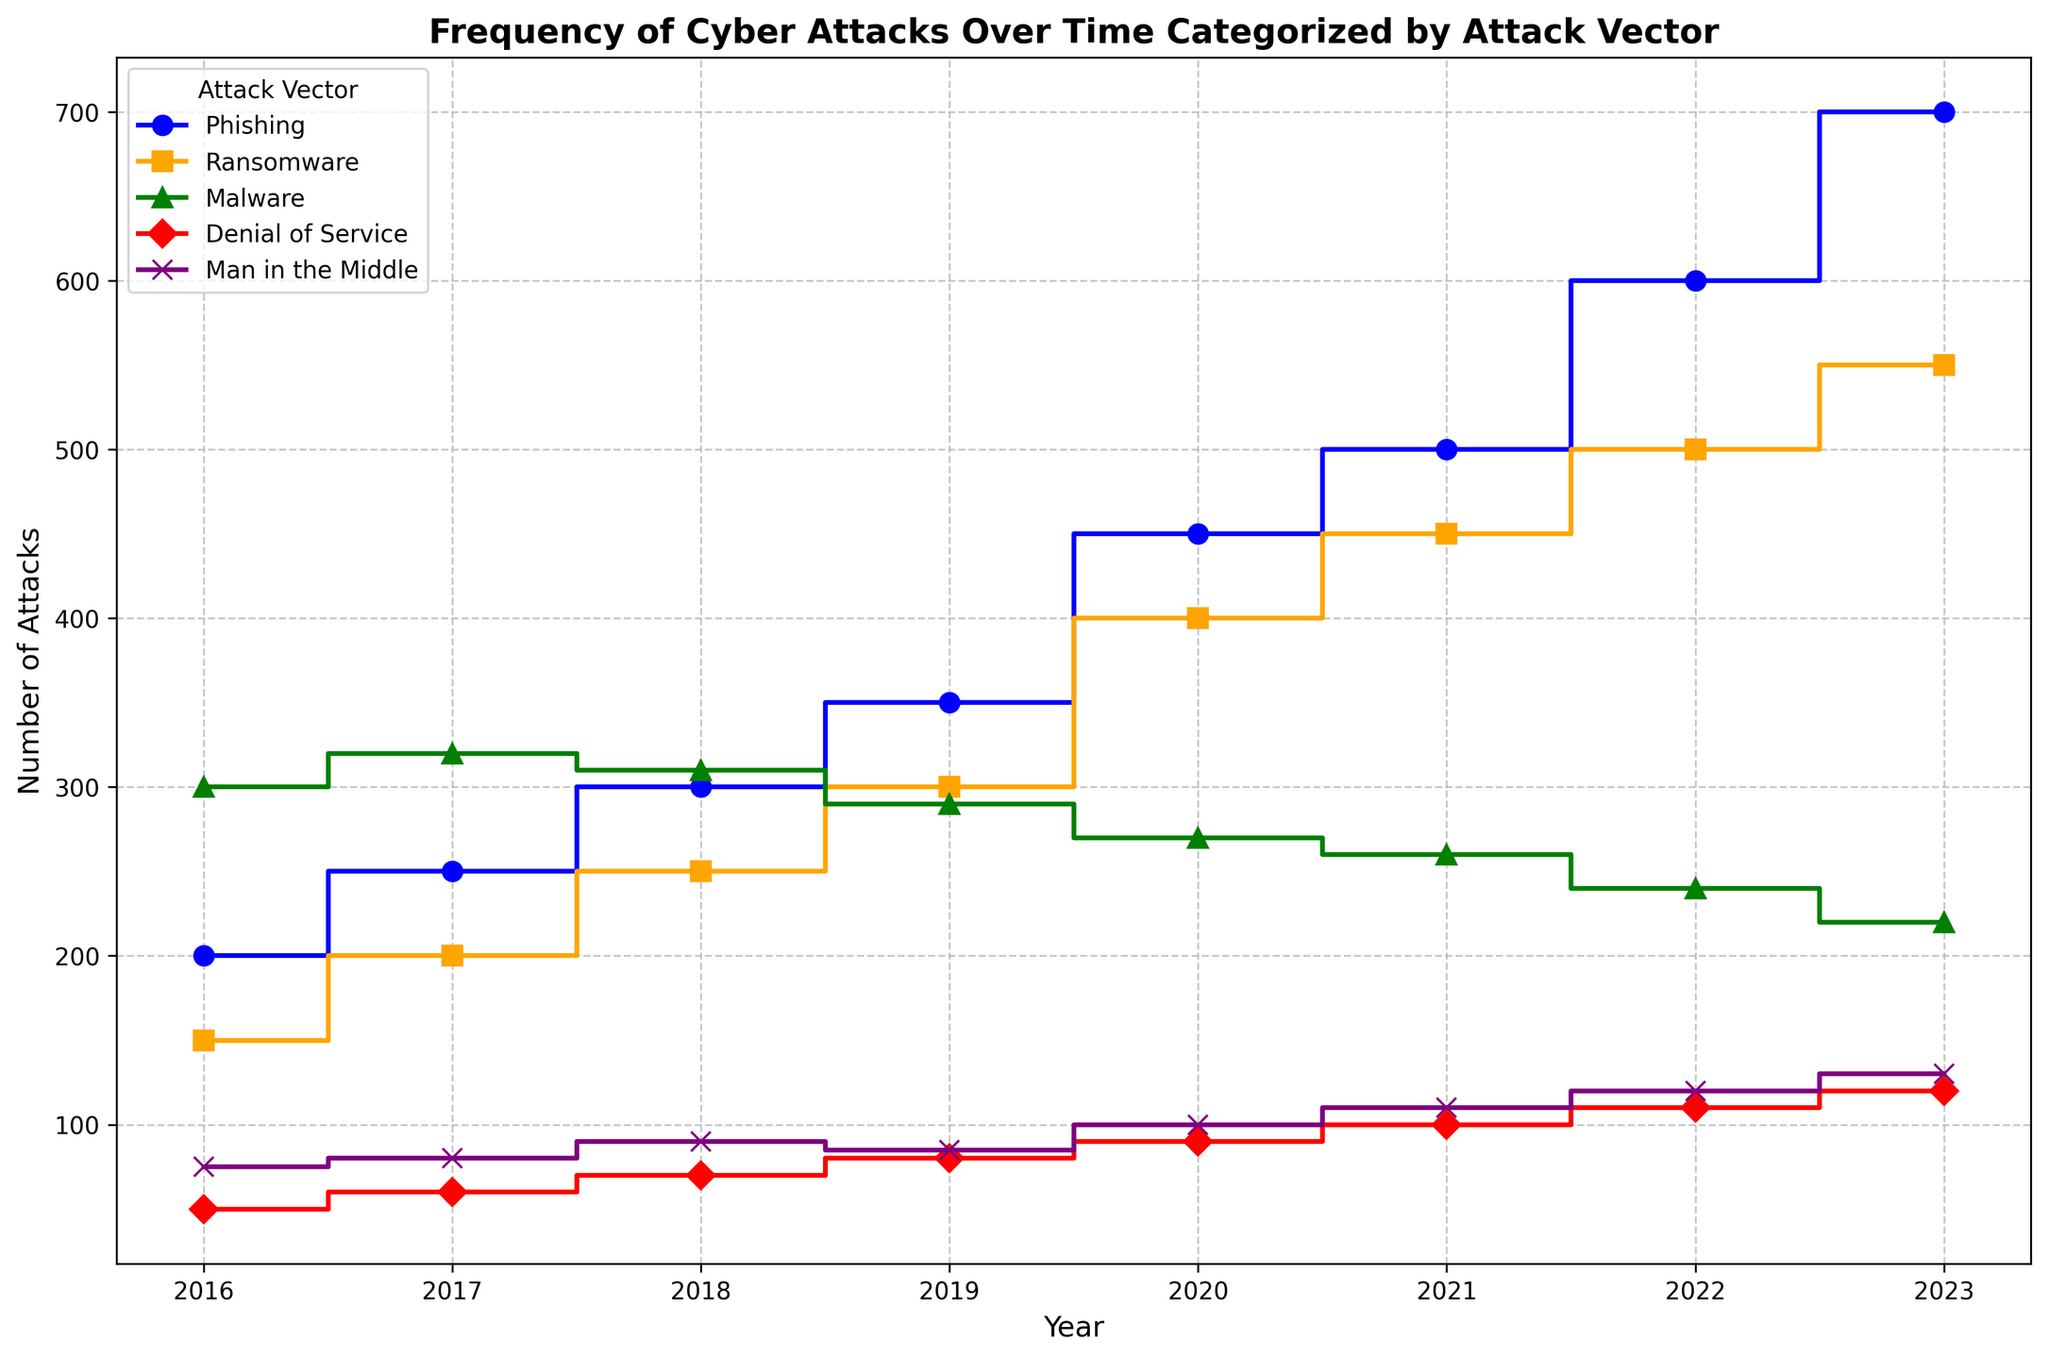What's the overall trend of phishing attacks from 2016 to 2023? To identify the overall trend, we observe the pattern in the number of phishing attacks year by year. From 2016 to 2023, the number of phishing attacks steadily increases every year.
Answer: Increasing Which attack vector had the highest frequency of attacks in 2023? By comparing the heights of the lines' endpoints in 2023, we see that the phishing attacks have the highest value compared to other vectors.
Answer: Phishing In which year did malware attacks reach their peak, and what was the value? By examining the graph, we see that malware attacks were highest in 2017 with a frequency of 320.
Answer: 2017 with 320 attacks What's the difference in the number of ransomware attacks between 2016 and 2023? To find the difference, subtract the number of ransomware attacks in 2016 (150) from the number in 2023 (550). 550 - 150 = 400
Answer: 400 How many total phishing attacks occurred from 2016 to 2023? Add the number of phishing attacks for each year: 200 + 250 + 300 + 350 + 450 + 500 + 600 + 700 = 3350
Answer: 3350 How does the trend of denial of service attacks compare to man in the middle attacks between 2016 and 2023? By comparing the step lines, denial of service attacks have a slower and incrementally steady rise whereas man in the middle attacks have a slightly steeper increase, especially toward the end of the period.
Answer: Man in the middle attacks increased faster Which attack vector saw the least change in frequency from 2016 to 2023? By observing the changes, we see that malware attacks had the smallest overall change from 300 in 2016 to 220 in 2023. The difference is 80, which is smaller compared to other vectors.
Answer: Malware What is the average number of denial of service attacks from 2016 to 2023? Add the number of denial of service attacks for each year and divide by the number of years: (50 + 60 + 70 + 80 + 90 + 100 + 110 + 120) / 8 = 680 / 8 = 85
Answer: 85 